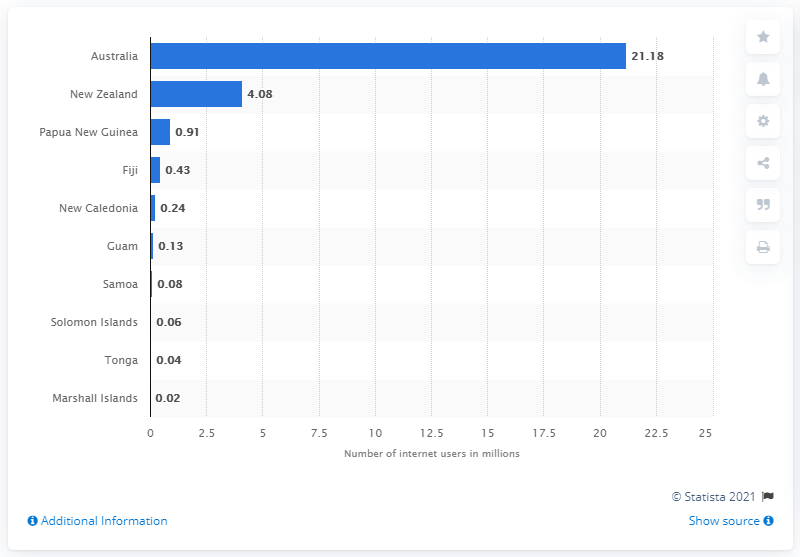Give some essential details in this illustration. In January 2017, the number of internet users in Australia was 21.18 million. In January 2017, there were approximately 4.08 million internet users in New Zealand. 